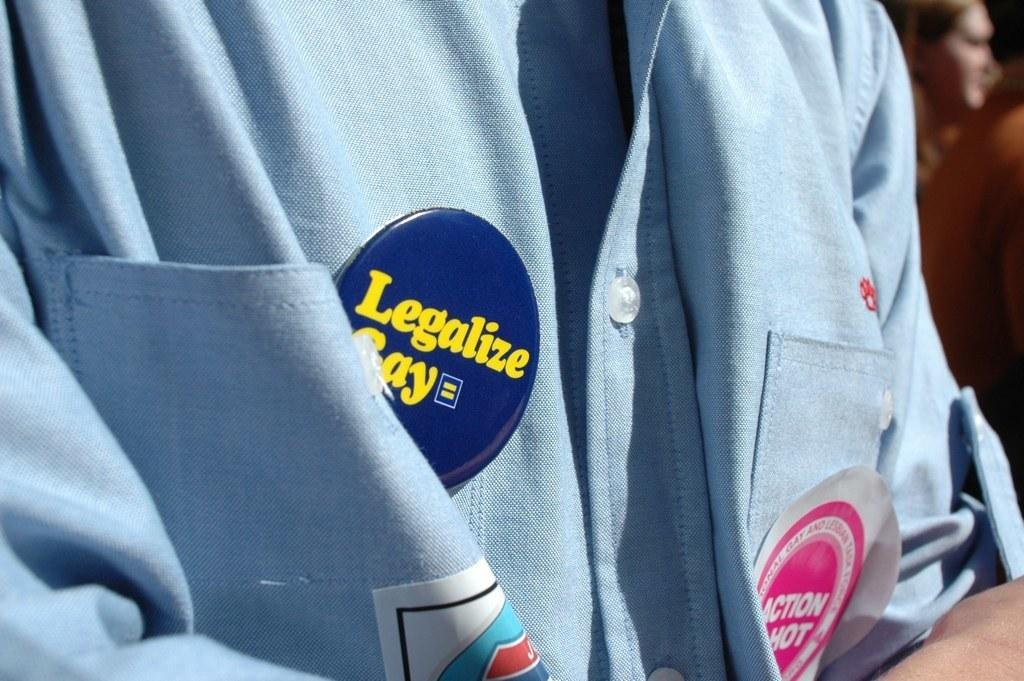<image>
Summarize the visual content of the image. Someone wearing a blue shirt has a "Legalize Gay" button on to show solidarity. 